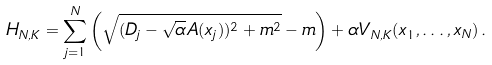<formula> <loc_0><loc_0><loc_500><loc_500>H _ { N , K } = \sum _ { j = 1 } ^ { N } \left ( \sqrt { ( D _ { j } - \sqrt { \alpha } A ( x _ { j } ) ) ^ { 2 } + m ^ { 2 } } - m \right ) + \alpha V _ { N , K } ( x _ { 1 } , \dots , x _ { N } ) \, .</formula> 